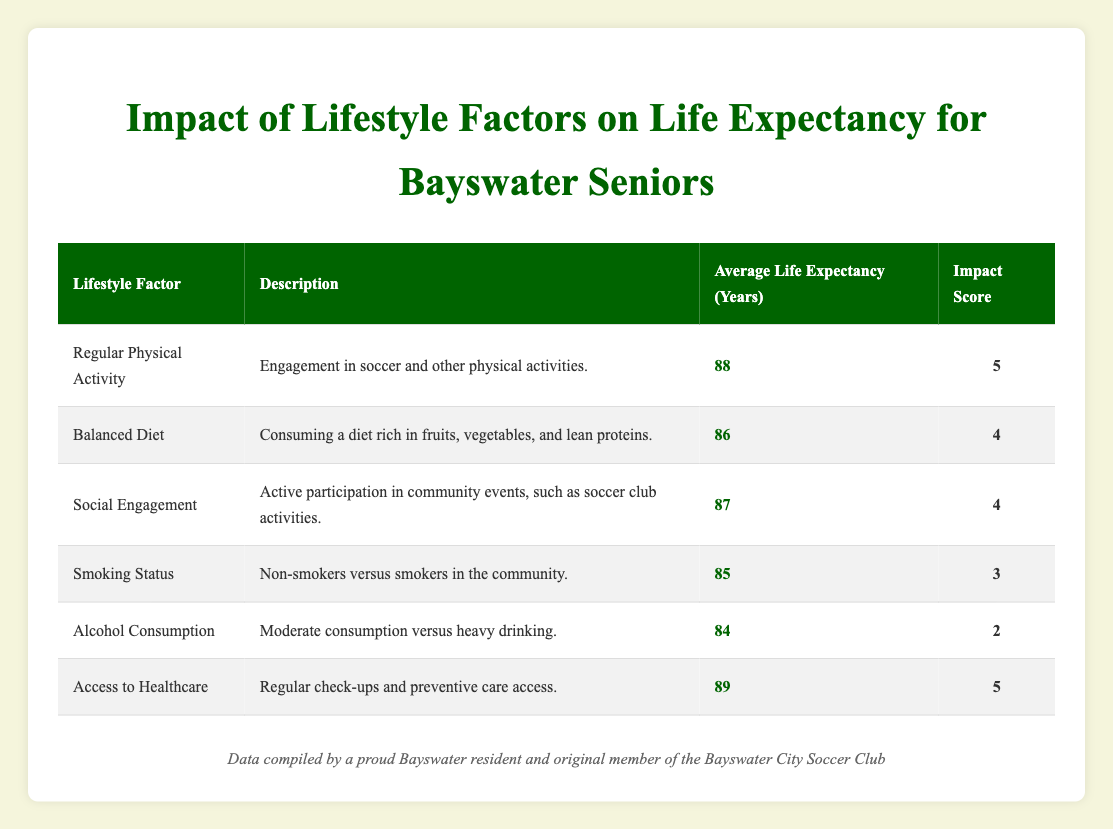What is the average life expectancy for seniors who engage in regular physical activity? The table shows that the average life expectancy for seniors engaging in regular physical activity is 88 years.
Answer: 88 years Which lifestyle factor has the highest impact score? In the table, both "Regular Physical Activity" and "Access to Healthcare" have the highest impact score of 5.
Answer: Regular Physical Activity and Access to Healthcare What is the difference in average life expectancy between those with access to healthcare and those with a balanced diet? The average life expectancy with access to healthcare is 89 years, while with a balanced diet it is 86 years. The difference is 89 - 86 = 3 years.
Answer: 3 years Is the average life expectancy for non-smokers higher than for moderate alcohol consumers? The average life expectancy for non-smokers is 85 years, while for moderate alcohol consumers, it is 84 years. Therefore, the statement is true.
Answer: Yes What is the average life expectancy for seniors participating in social engagement activities? The table lists the average life expectancy for seniors participating in social engagement activities as 87 years.
Answer: 87 years If a senior maintains a balanced diet and does not smoke, what is the average life expectancy? The average life expectancy for seniors with a balanced diet is 86 years, and for non-smokers (who have the same score as smokers at 85) would average out to (86 + 85) / 2 = 85.5. Since we are looking at two lifestyle factors that affect the same group, we take the balanced diet as the stronger lifestyle factor, resulting in an average of 86 years.
Answer: 86 years What is the average life expectancy for seniors with heavy alcohol consumption? The table shows that the average life expectancy for seniors with heavy alcohol consumption is 84 years.
Answer: 84 years How do the average life expectancies change when comparing those who are engaged socially versus those who consume alcohol moderately? The average life expectancy for socially engaged seniors is 87 years, while for those with moderate alcohol consumption it is 84 years. The difference is 87 - 84 = 3 years, indicating that social engagement leads to 3 more years of life expectancy.
Answer: 3 years 